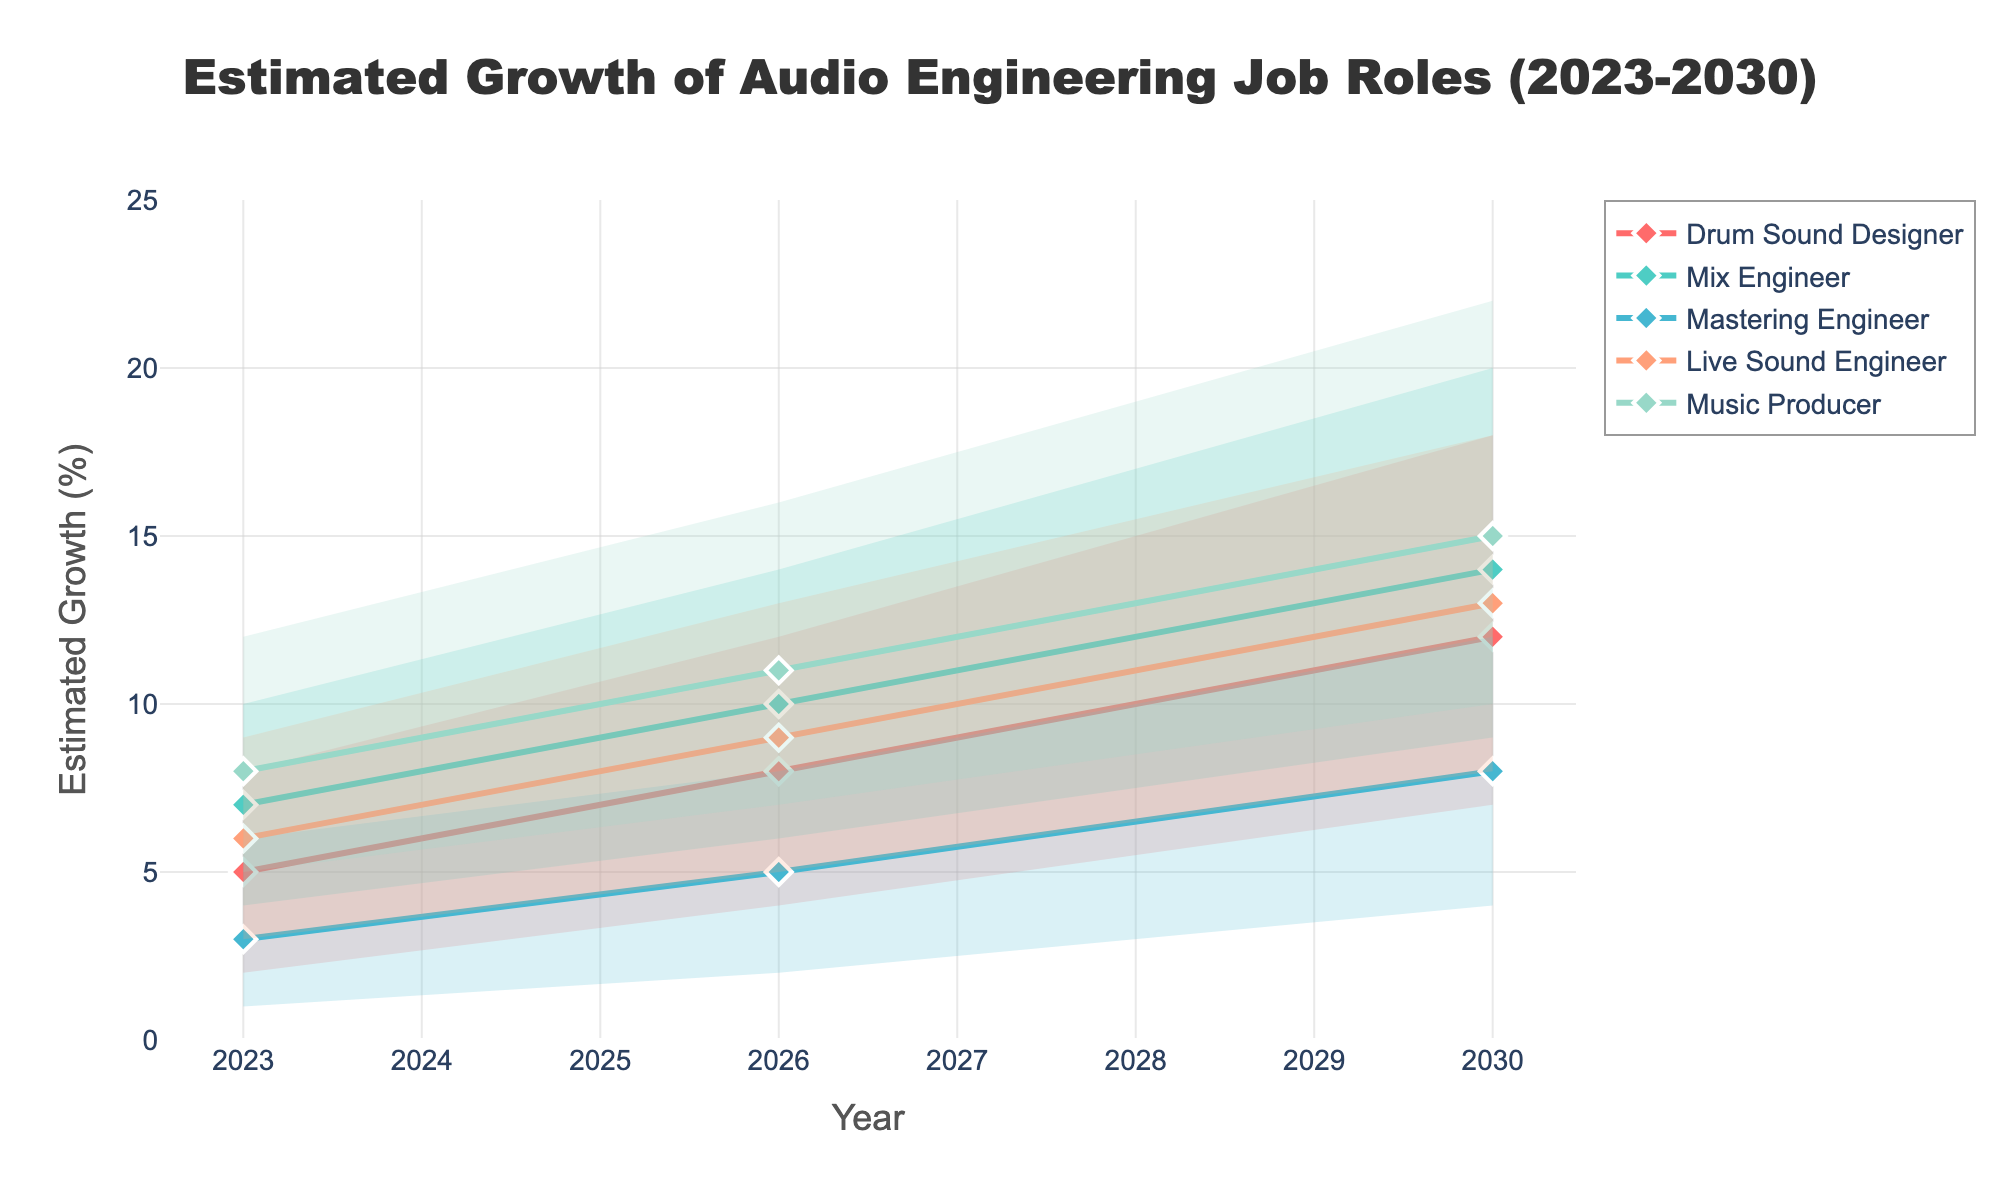What is the title of the chart? The title is located at the top of the chart in a larger font size compared to the other text on the figure.
Answer: Estimated Growth of Audio Engineering Job Roles (2023-2030) Which job role has the highest median estimate in 2030? Look for the median estimate values for each role in 2030 and compare them. The highest median estimate is represented by a marker with a corresponding label on the x-axis.
Answer: Music Producer How much is the median estimate for Live Sound Engineer expected to grow from 2023 to 2030? Find the median estimate value for Live Sound Engineer in 2023 and 2030, then subtract the former from the latter.
Answer: 7% What is the estimated range for Mix Engineer in 2026? The range is determined by the low and high estimate values for the role in 2026 as shown by the upper and lower bounds of the shaded area.
Answer: 6% to 14% Which role shows the highest variability in growth estimates in 2030? Variability can be assessed by the difference between the high and low estimate values. Identify the role with the largest difference in 2030.
Answer: Drum Sound Designer In which year do Music Producers have the lowest median estimate? Look for the median estimate of Music Producers in each year and identify the year with the lowest value.
Answer: 2023 How many years are depicted in the chart? Count the unique years displayed along the x-axis.
Answer: 3 Between 2023 and 2026, which role has the greatest increase in the highest estimate? Find the change in the high estimate value for each role between 2023 and 2026 and identify the role with the greatest increase.
Answer: Drum Sound Designer How does the median estimate for Drum Sound Designer in 2026 compare to that of Live Sound Engineer in the same year? Compare the median estimate values for Drum Sound Designer and Live Sound Engineer in 2026.
Answer: Lower Which role has the smallest increase in high estimates from 2023 to 2030? Calculate the difference in high estimates for each role between 2023 and 2030 and find the smallest value.
Answer: Mastering Engineer 